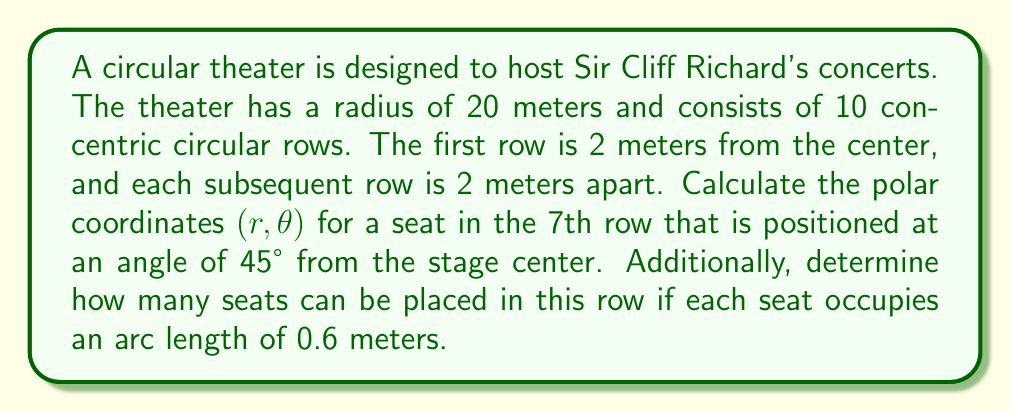Show me your answer to this math problem. To solve this problem, we'll use polar coordinates and basic geometry concepts:

1. Finding the radius (r) for the 7th row:
   - The first row is 2 meters from the center
   - Each row is 2 meters apart
   - For the 7th row: $r = 2 + (7-1) \times 2 = 2 + 6 \times 2 = 14$ meters

2. The angle $\theta$ is given as 45°, which is $\frac{\pi}{4}$ radians

3. Therefore, the polar coordinates for the seat are $(14, \frac{\pi}{4})$

4. To calculate the number of seats in the 7th row:
   - Circumference of the 7th row: $C = 2\pi r = 2\pi(14) \approx 87.96$ meters
   - Number of seats = $\frac{\text{Circumference}}{\text{Arc length per seat}} = \frac{87.96}{0.6} \approx 146.6$

5. Rounding down to the nearest whole number (as we can't have partial seats), we get 146 seats in the 7th row.
Answer: The polar coordinates of the seat are $(14, \frac{\pi}{4})$, and the 7th row can accommodate 146 seats. 